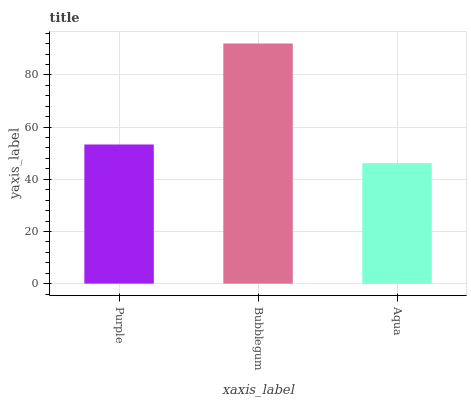Is Aqua the minimum?
Answer yes or no. Yes. Is Bubblegum the maximum?
Answer yes or no. Yes. Is Bubblegum the minimum?
Answer yes or no. No. Is Aqua the maximum?
Answer yes or no. No. Is Bubblegum greater than Aqua?
Answer yes or no. Yes. Is Aqua less than Bubblegum?
Answer yes or no. Yes. Is Aqua greater than Bubblegum?
Answer yes or no. No. Is Bubblegum less than Aqua?
Answer yes or no. No. Is Purple the high median?
Answer yes or no. Yes. Is Purple the low median?
Answer yes or no. Yes. Is Aqua the high median?
Answer yes or no. No. Is Bubblegum the low median?
Answer yes or no. No. 